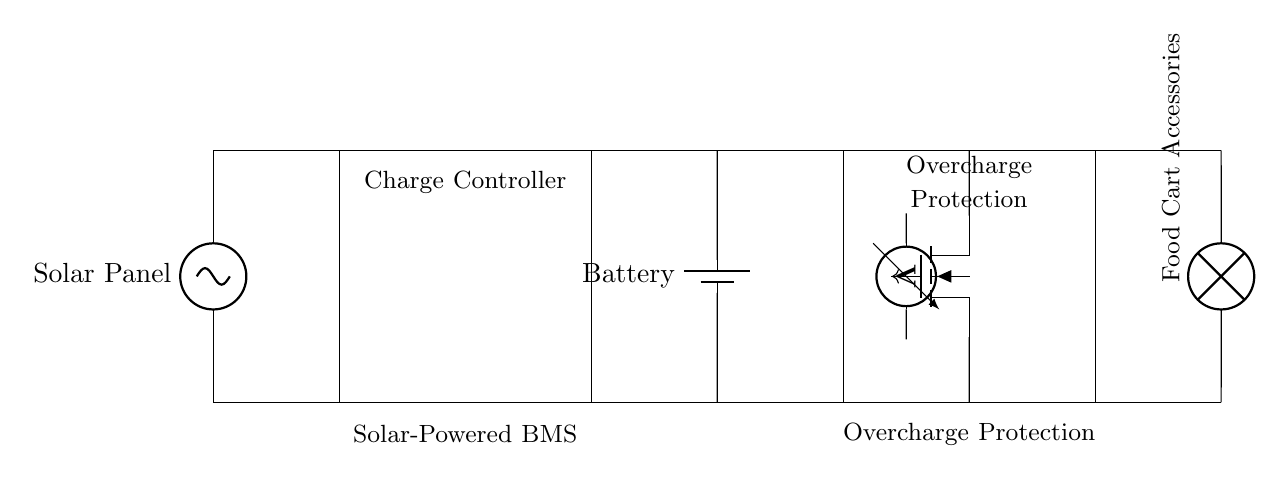What is the main function of the charge controller? The charge controller regulates the voltage and current from the solar panel to the battery, preventing overcharging.
Answer: regulate voltage and current What type of protection does the overcharge protection circuit provide? The overcharge protection circuit prevents the battery from being charged beyond its maximum capacity, ensuring safety and longevity.
Answer: prevents overcharging What component acts as a switch in the overcharge protection circuit? The MOSFET acts as a switch to control the charging path from the battery to the load based on the control signal.
Answer: MOSFET How many main components are seen in the circuit diagram? The circuit contains four main components: solar panel, charge controller, battery, and overcharge protection circuit.
Answer: four What is the role of the voltage sensor in the circuit? The voltage sensor monitors the battery voltage and provides feedback to the control signal to the MOSFET for overcharge protection.
Answer: monitor battery voltage What is the load represented in the circuit diagram? The load in the diagram is the "Food Cart Accessories," which are powered by the battery through the overcharge protection circuit.
Answer: Food Cart Accessories 